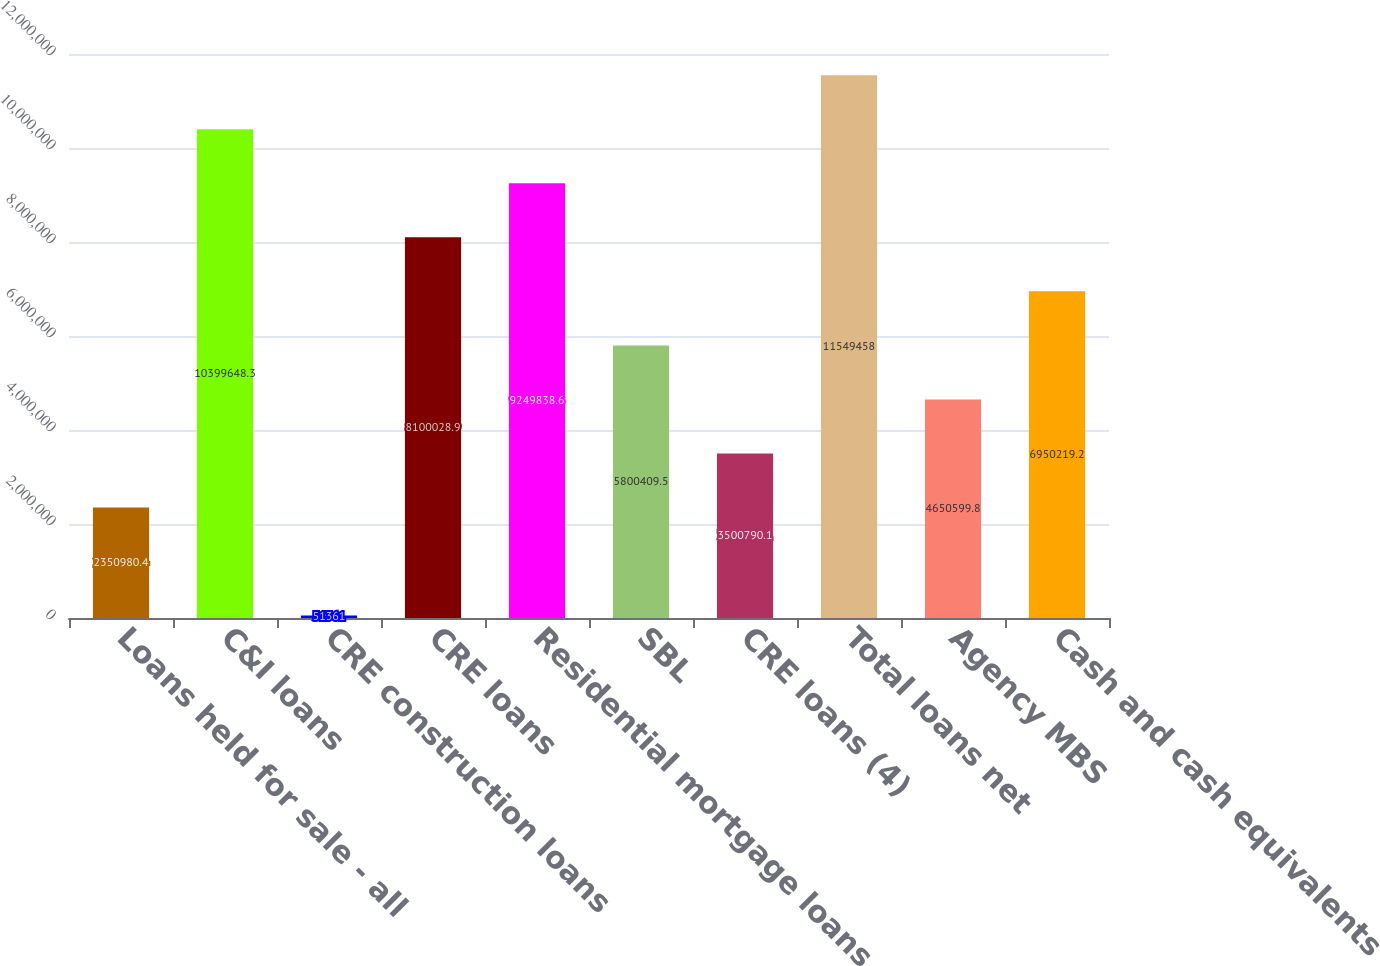Convert chart. <chart><loc_0><loc_0><loc_500><loc_500><bar_chart><fcel>Loans held for sale - all<fcel>C&I loans<fcel>CRE construction loans<fcel>CRE loans<fcel>Residential mortgage loans<fcel>SBL<fcel>CRE loans (4)<fcel>Total loans net<fcel>Agency MBS<fcel>Cash and cash equivalents<nl><fcel>2.35098e+06<fcel>1.03996e+07<fcel>51361<fcel>8.10003e+06<fcel>9.24984e+06<fcel>5.80041e+06<fcel>3.50079e+06<fcel>1.15495e+07<fcel>4.6506e+06<fcel>6.95022e+06<nl></chart> 